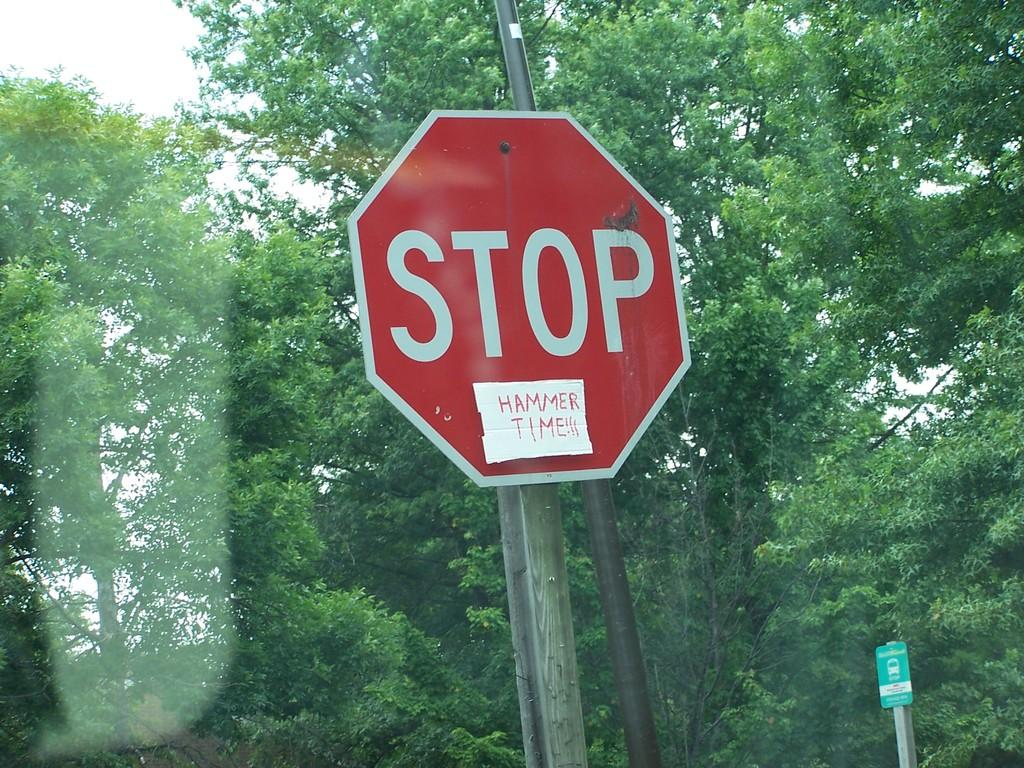<image>
Share a concise interpretation of the image provided. Stop Sign that has a note on it saying Hammer Time! 